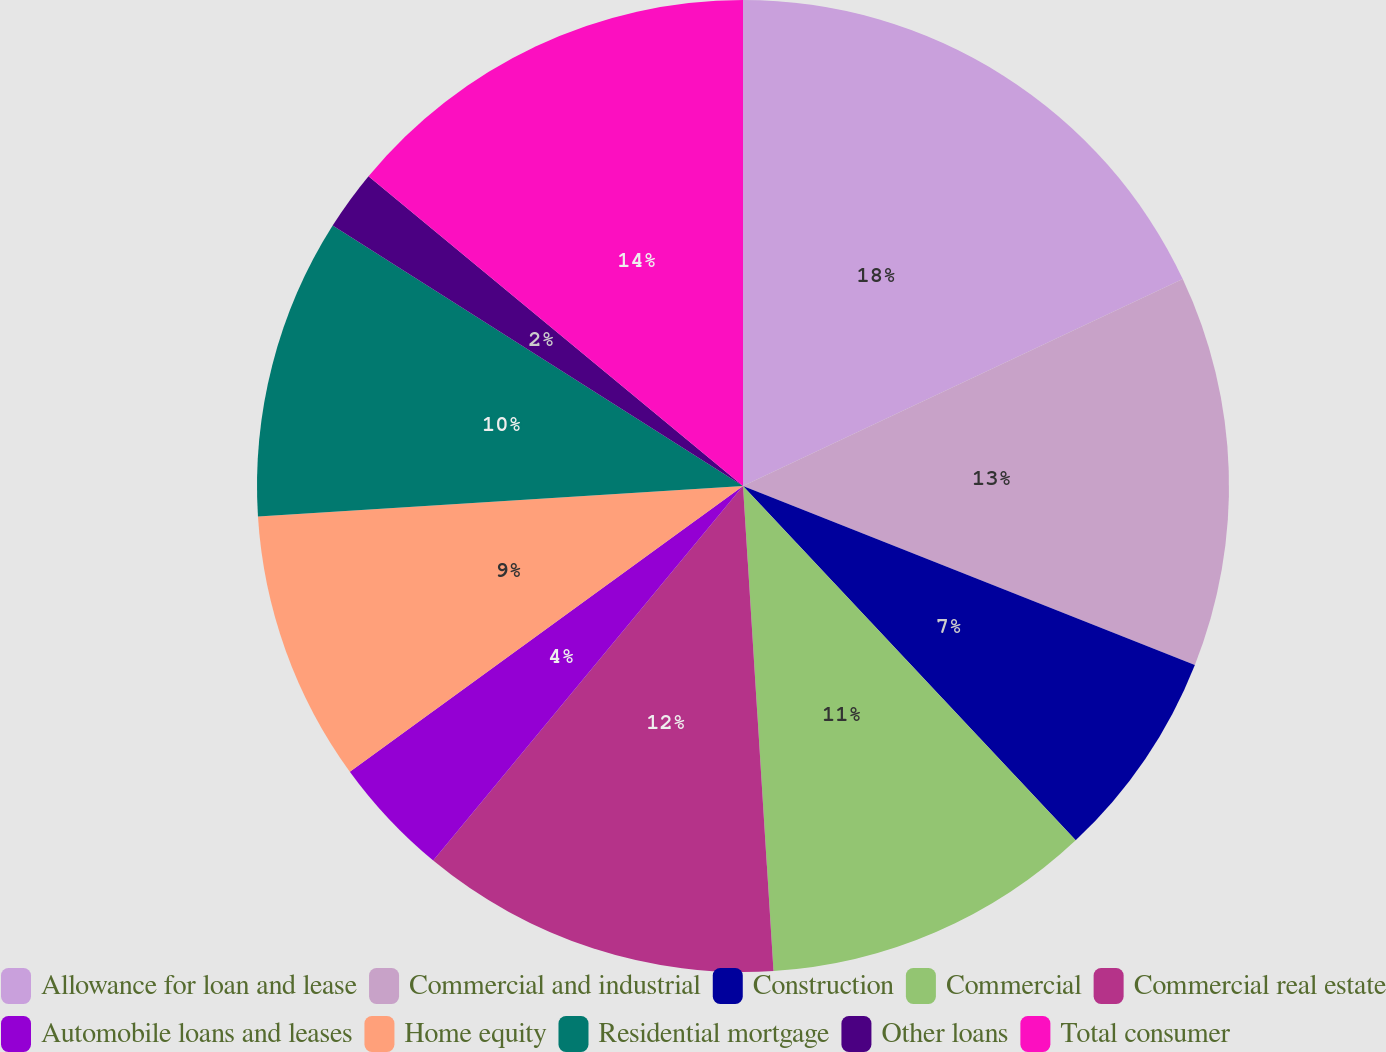<chart> <loc_0><loc_0><loc_500><loc_500><pie_chart><fcel>Allowance for loan and lease<fcel>Commercial and industrial<fcel>Construction<fcel>Commercial<fcel>Commercial real estate<fcel>Automobile loans and leases<fcel>Home equity<fcel>Residential mortgage<fcel>Other loans<fcel>Total consumer<nl><fcel>18.0%<fcel>13.0%<fcel>7.0%<fcel>11.0%<fcel>12.0%<fcel>4.0%<fcel>9.0%<fcel>10.0%<fcel>2.0%<fcel>14.0%<nl></chart> 